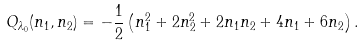<formula> <loc_0><loc_0><loc_500><loc_500>Q _ { \lambda _ { 0 } } ( n _ { 1 } , n _ { 2 } ) = - \frac { 1 } { 2 } \left ( n _ { 1 } ^ { 2 } + 2 n _ { 2 } ^ { 2 } + 2 n _ { 1 } n _ { 2 } + 4 n _ { 1 } + 6 n _ { 2 } \right ) .</formula> 